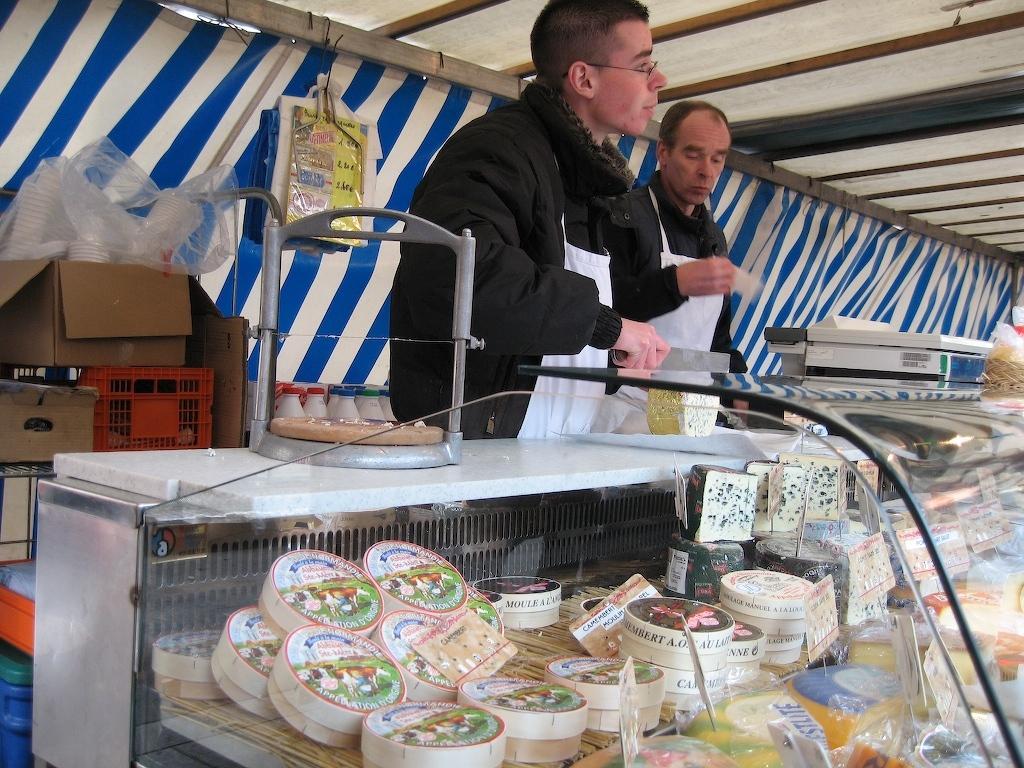Can you describe this image briefly? Here we can see food items on the racks and it is covered with a glass plate and on the table we can see metal object,an electronic device and food items. In the background there are two men standing,carton boxes and plastic boxes on the left side and they are under a tent and we can see wooden poles and there are covers here. 